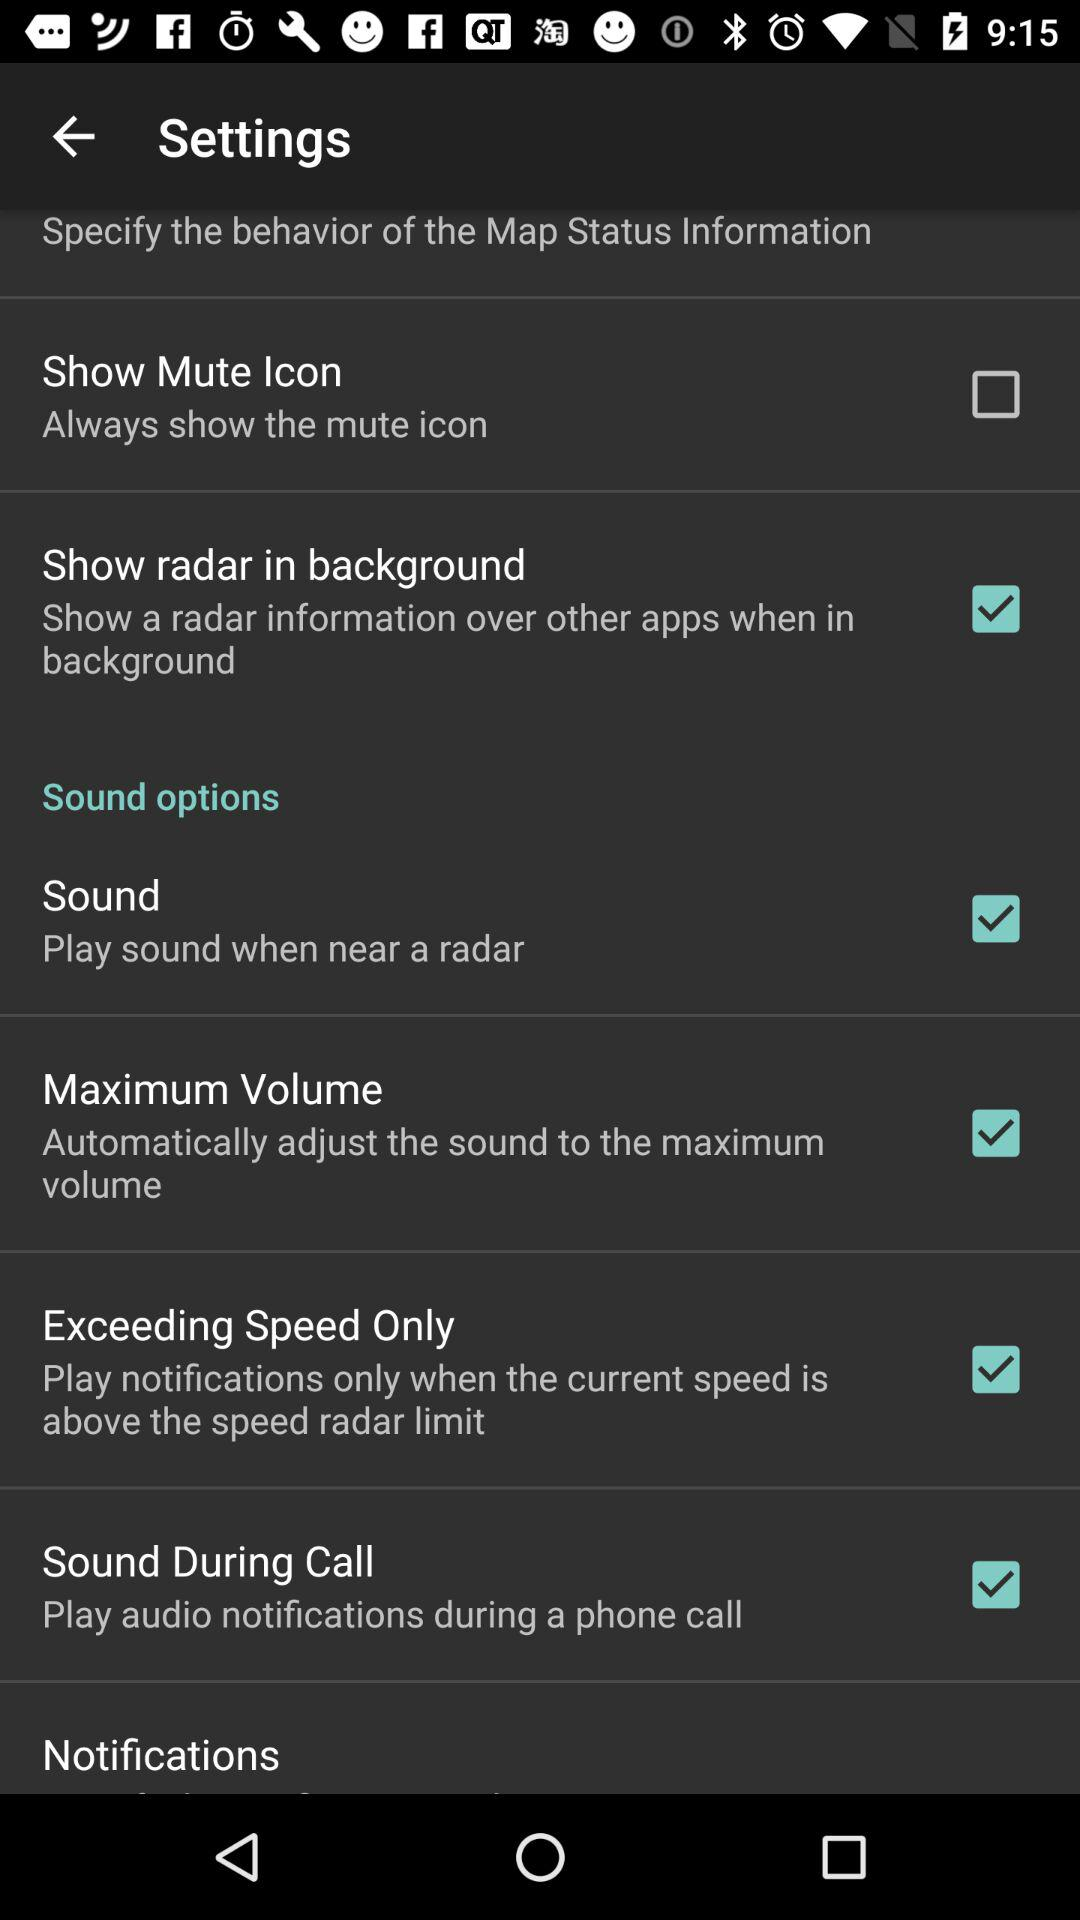When will the "Exceeding Speed Only" notification play? The "Exceeding Speed Only" notification play "only when the current speed is above the speed radar limit". 